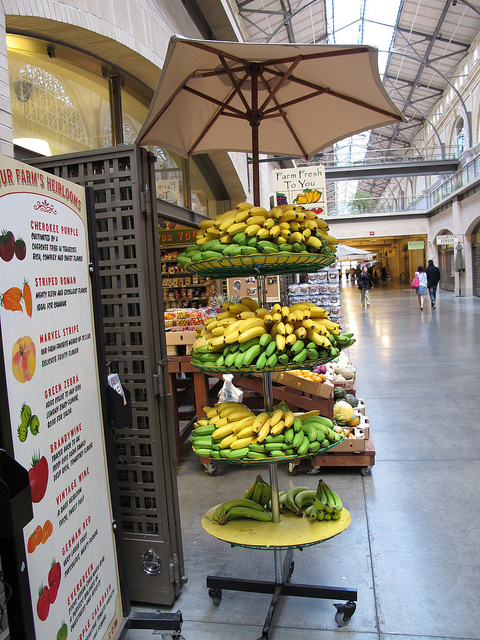Identify and read out the text in this image. FARM'S HEIRLOOMS GREEn UR Fresh You 